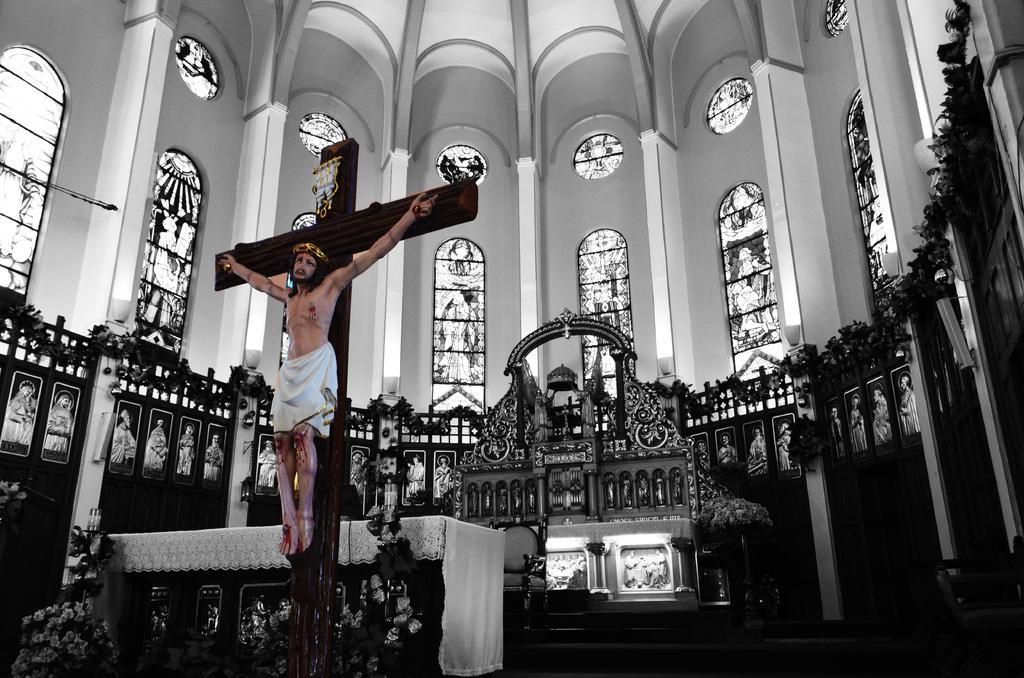In one or two sentences, can you explain what this image depicts? In the foreground of this image, there is a sculpture to the cross symbol and behind it, there is a table with white cloth, candle holders, plants and flowers. In the background, there is the wall of the church with few lights and plants to it. In the background, there is a chair and few sculptures to the wall. 